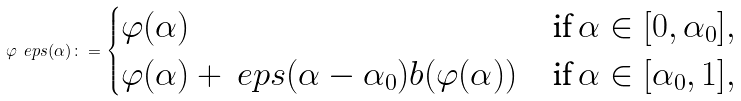<formula> <loc_0><loc_0><loc_500><loc_500>\varphi _ { \ } e p s ( \alpha ) \colon = \begin{cases} \varphi ( \alpha ) & \text {if } \alpha \in [ 0 , \alpha _ { 0 } ] , \\ \varphi ( \alpha ) + \ e p s ( \alpha - \alpha _ { 0 } ) b ( \varphi ( \alpha ) ) & \text {if } \alpha \in [ \alpha _ { 0 } , 1 ] , \end{cases}</formula> 